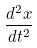Convert formula to latex. <formula><loc_0><loc_0><loc_500><loc_500>\frac { d ^ { 2 } x } { d t ^ { 2 } }</formula> 